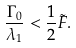Convert formula to latex. <formula><loc_0><loc_0><loc_500><loc_500>\frac { \Gamma _ { 0 } } { \lambda _ { 1 } } < \frac { 1 } { 2 } \tilde { F } .</formula> 